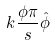Convert formula to latex. <formula><loc_0><loc_0><loc_500><loc_500>k \frac { \phi \pi } { s } \hat { \phi }</formula> 